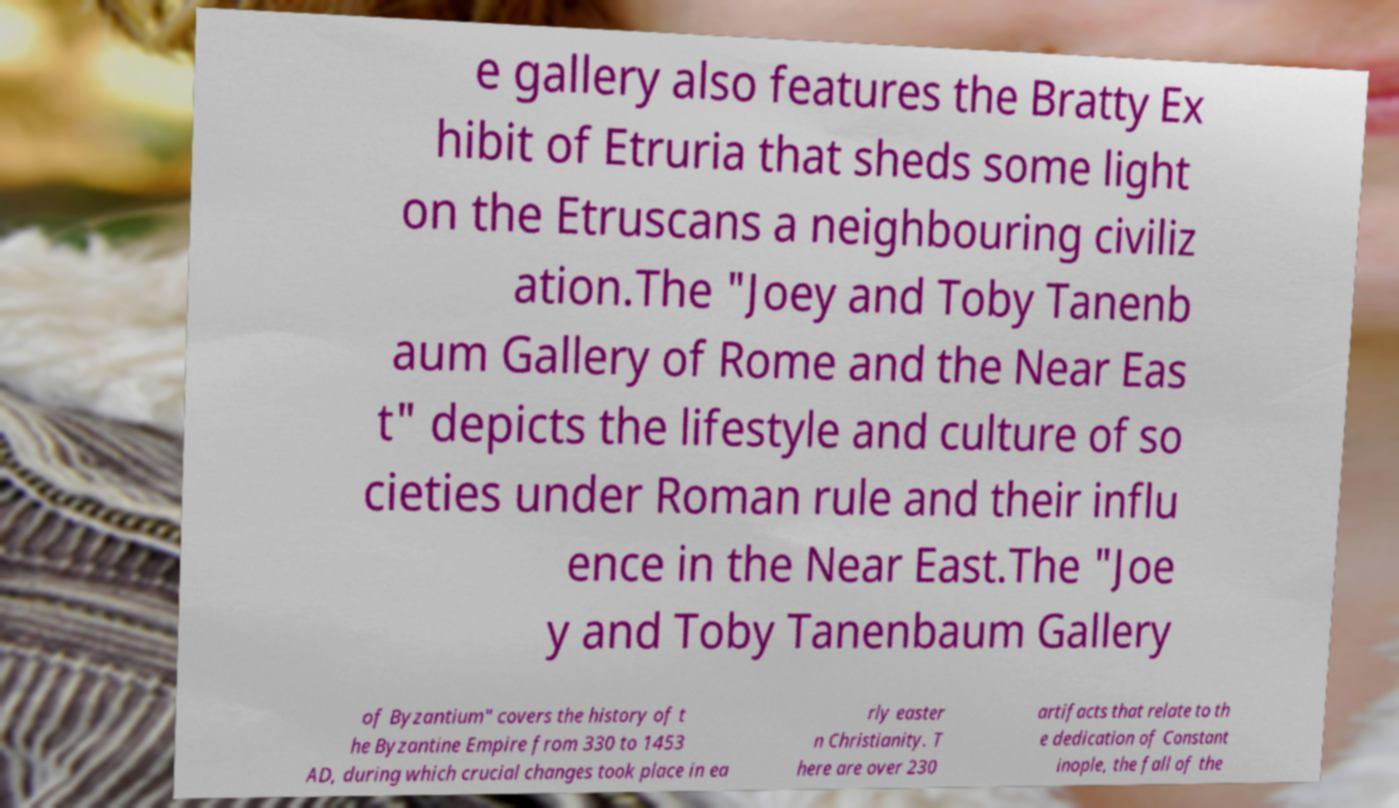For documentation purposes, I need the text within this image transcribed. Could you provide that? e gallery also features the Bratty Ex hibit of Etruria that sheds some light on the Etruscans a neighbouring civiliz ation.The "Joey and Toby Tanenb aum Gallery of Rome and the Near Eas t" depicts the lifestyle and culture of so cieties under Roman rule and their influ ence in the Near East.The "Joe y and Toby Tanenbaum Gallery of Byzantium" covers the history of t he Byzantine Empire from 330 to 1453 AD, during which crucial changes took place in ea rly easter n Christianity. T here are over 230 artifacts that relate to th e dedication of Constant inople, the fall of the 